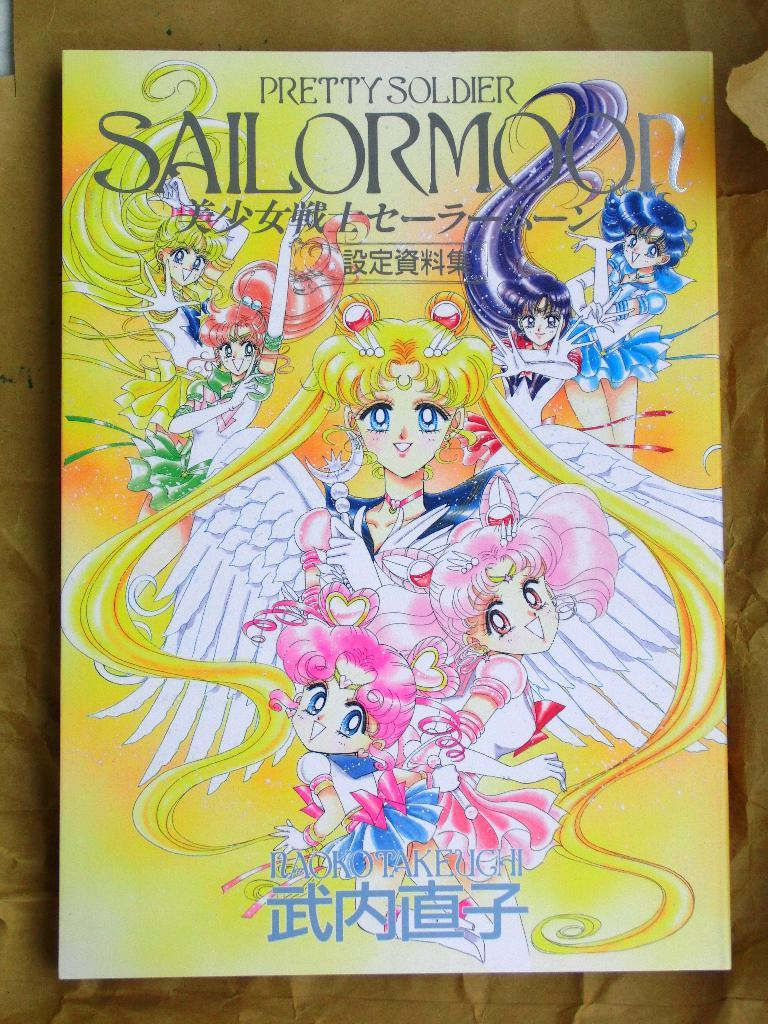<image>
Describe the image concisely. A poster titled Pretty Soldier Sailor Moon with asian text. 